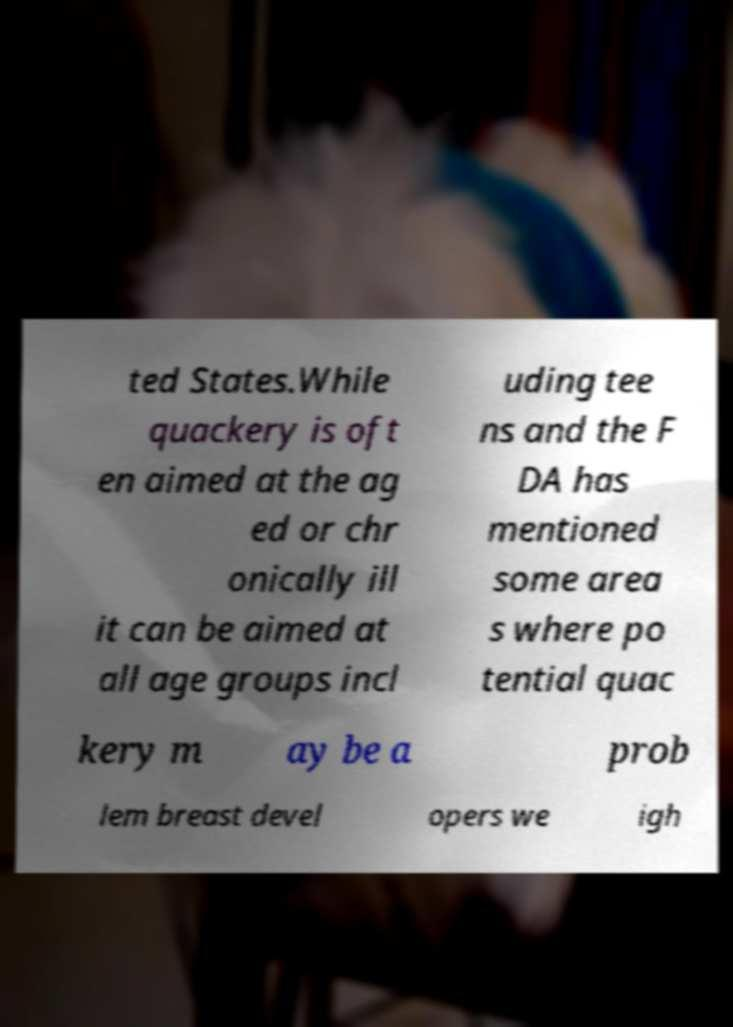Could you extract and type out the text from this image? ted States.While quackery is oft en aimed at the ag ed or chr onically ill it can be aimed at all age groups incl uding tee ns and the F DA has mentioned some area s where po tential quac kery m ay be a prob lem breast devel opers we igh 